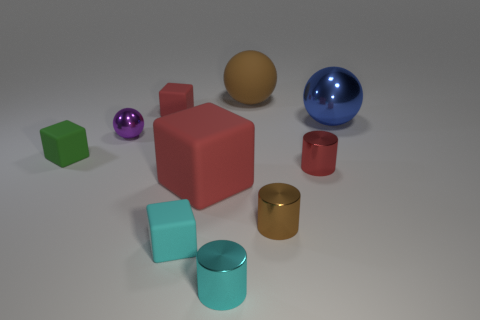There is a small cylinder that is the same color as the large rubber cube; what material is it?
Provide a succinct answer. Metal. What number of cylinders are big blue matte objects or cyan metallic things?
Give a very brief answer. 1. What is the size of the cylinder that is the same color as the large rubber cube?
Your response must be concise. Small. Are there fewer rubber blocks that are in front of the blue metallic thing than tiny gray shiny spheres?
Your answer should be very brief. No. What color is the matte thing that is both behind the green thing and on the right side of the small cyan rubber object?
Your answer should be very brief. Brown. How many other things are the same shape as the red metallic thing?
Ensure brevity in your answer.  2. Are there fewer red cylinders that are behind the small purple shiny object than tiny green cubes behind the small green matte cube?
Make the answer very short. No. Do the small sphere and the brown object in front of the green thing have the same material?
Offer a very short reply. Yes. Is there anything else that is the same material as the big brown thing?
Your answer should be compact. Yes. Is the number of big gray cylinders greater than the number of tiny green matte blocks?
Your answer should be compact. No. 